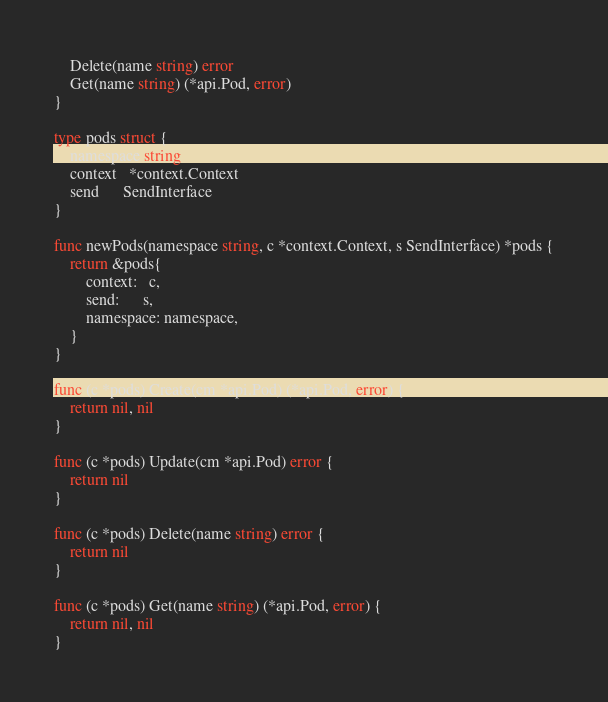Convert code to text. <code><loc_0><loc_0><loc_500><loc_500><_Go_>	Delete(name string) error
	Get(name string) (*api.Pod, error)
}

type pods struct {
	namespace string
	context   *context.Context
	send      SendInterface
}

func newPods(namespace string, c *context.Context, s SendInterface) *pods {
	return &pods{
		context:   c,
		send:      s,
		namespace: namespace,
	}
}

func (c *pods) Create(cm *api.Pod) (*api.Pod, error) {
	return nil, nil
}

func (c *pods) Update(cm *api.Pod) error {
	return nil
}

func (c *pods) Delete(name string) error {
	return nil
}

func (c *pods) Get(name string) (*api.Pod, error) {
	return nil, nil
}
</code> 